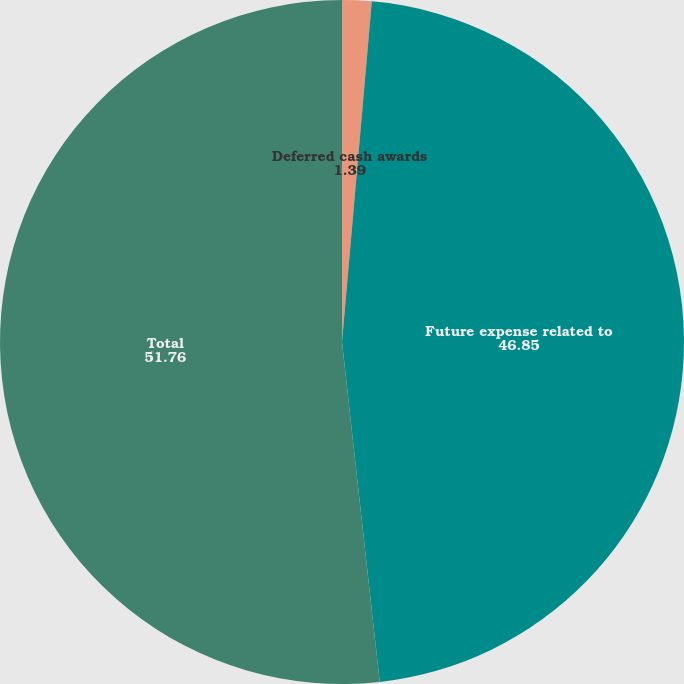<chart> <loc_0><loc_0><loc_500><loc_500><pie_chart><fcel>Deferred cash awards<fcel>Future expense related to<fcel>Total<nl><fcel>1.39%<fcel>46.85%<fcel>51.76%<nl></chart> 